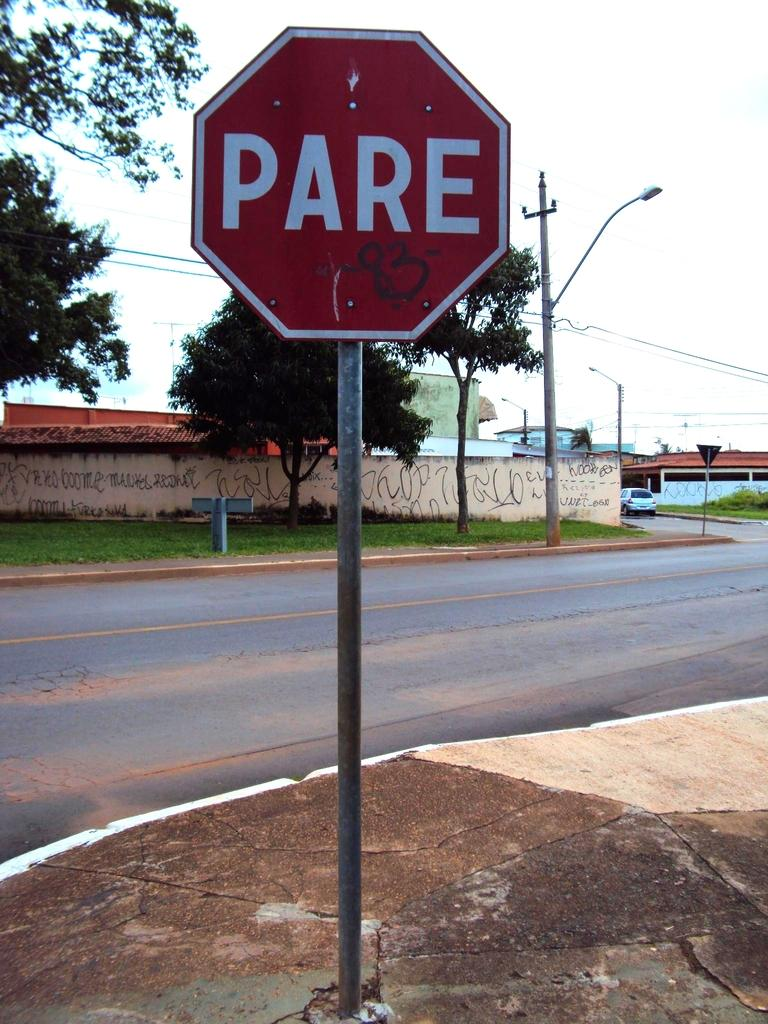<image>
Provide a brief description of the given image. A red sign with white letters spelling PARE. 